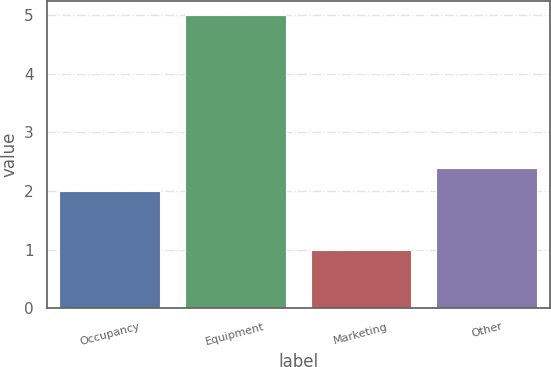Convert chart to OTSL. <chart><loc_0><loc_0><loc_500><loc_500><bar_chart><fcel>Occupancy<fcel>Equipment<fcel>Marketing<fcel>Other<nl><fcel>2<fcel>5<fcel>1<fcel>2.4<nl></chart> 